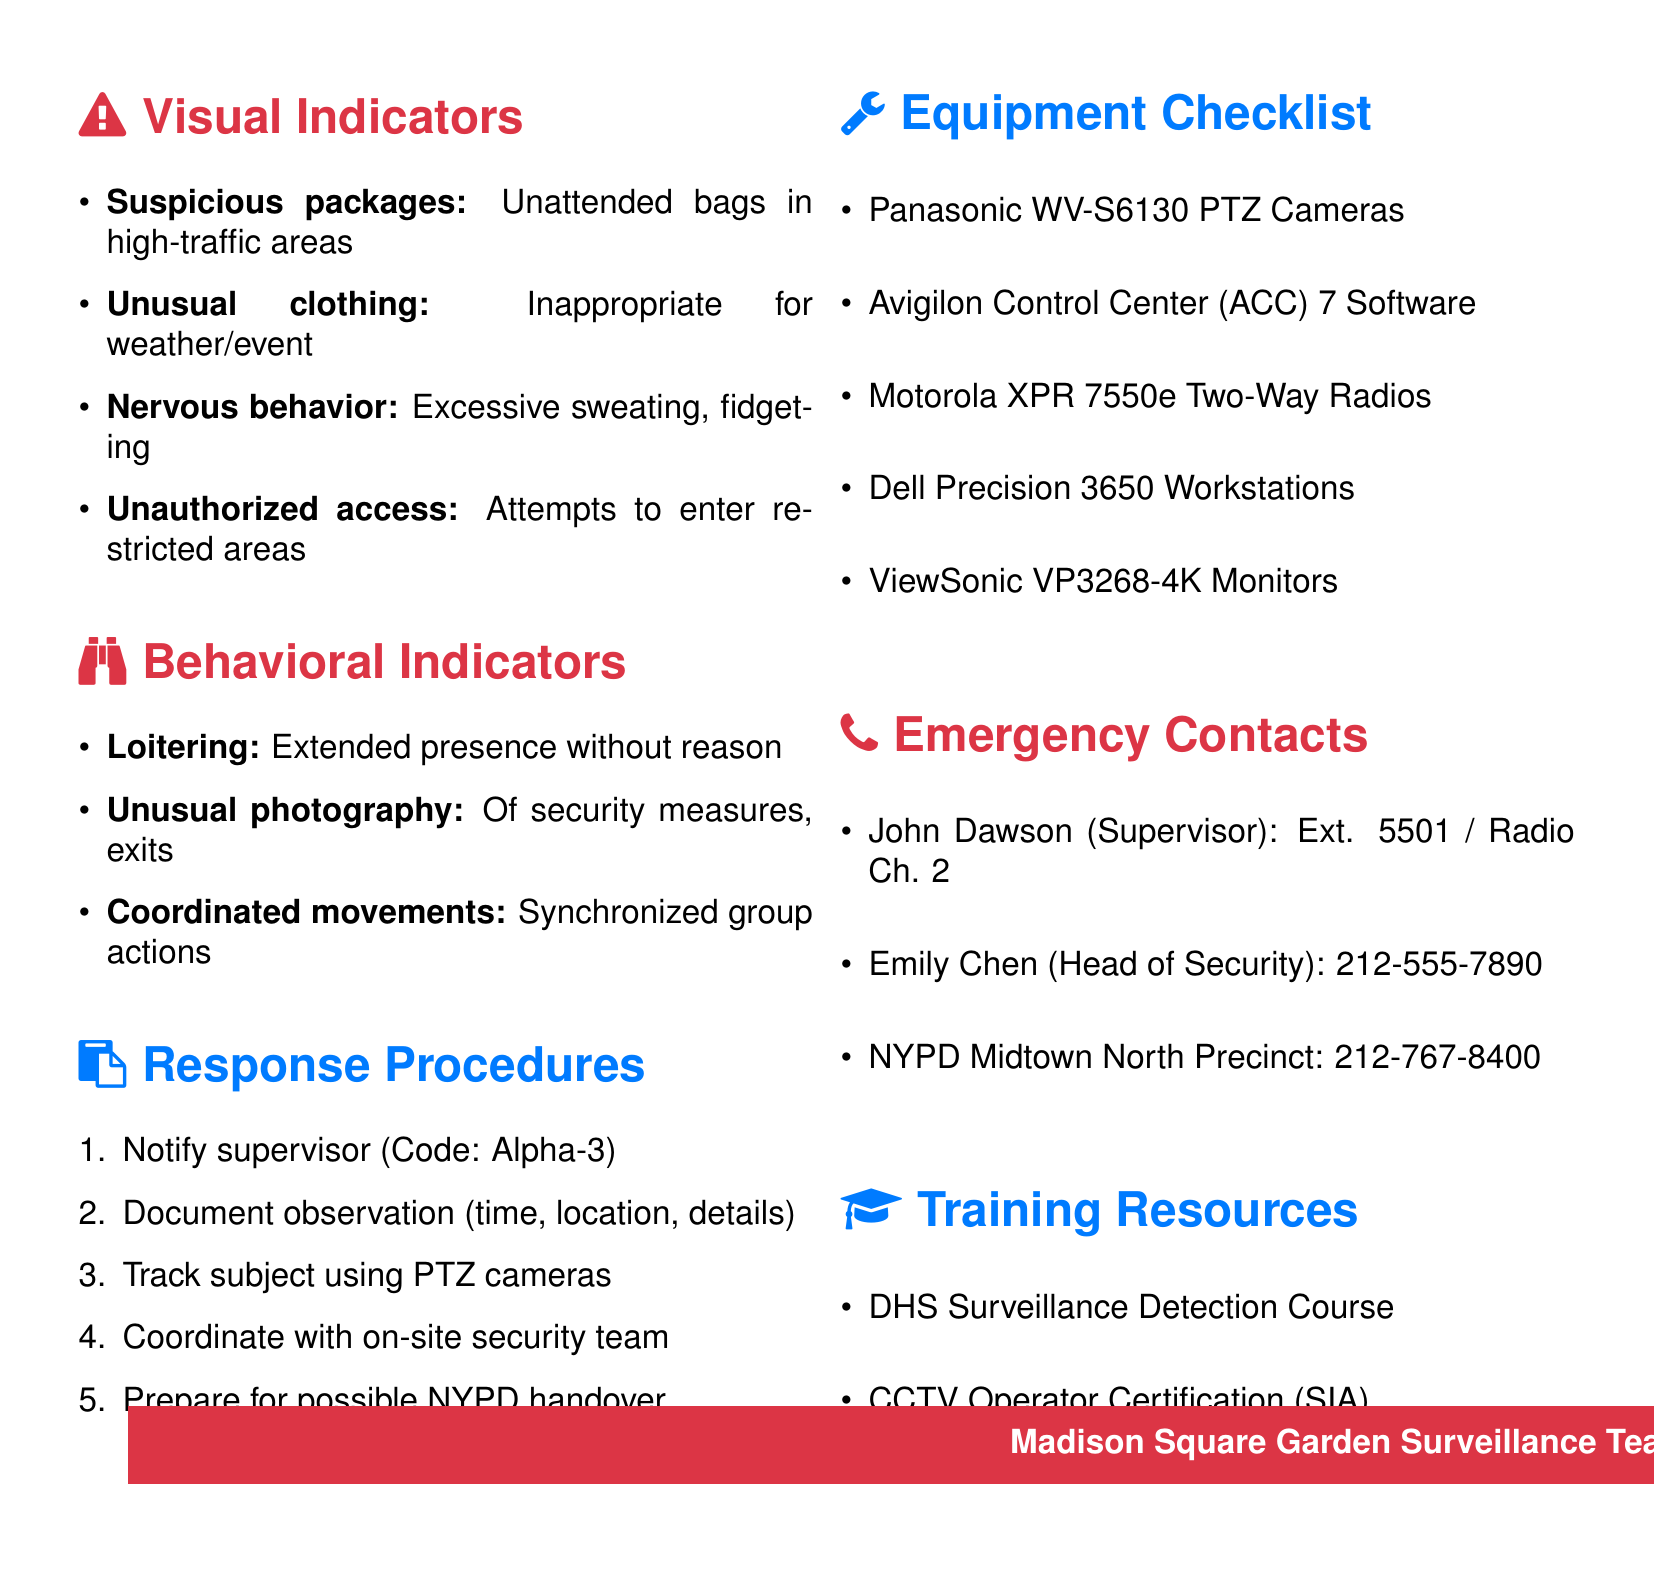what is the title of the memo? The title is located at the top of the document and describes the focus of the memo.
Answer: Training Memo: Recognizing Potential Threats in Crowded Environments who is the shift supervisor mentioned in the memo? The shift supervisor's name appears in the emergency contacts section of the document.
Answer: John Dawson how many steps are in the response procedures? The number of steps can be found by counting the listed items under response procedures.
Answer: 5 give an example of a suspicious package. An example can be found in the visual indicators section, describing a specific scenario.
Answer: A duffel bag left beneath a seat during a New York Knicks game what should you do first when you observe suspicious activity? The first action is outlined clearly at the start of the response procedures.
Answer: Notify supervisor which equipment is listed for use in surveillance? This information is contained in the equipment checklist section.
Answer: Panasonic WV-S6130 PTZ Cameras what kind of behavior should be documented? The document outlines specific behaviors that qualify for observation under the behavioral indicators.
Answer: Loitering how can you communicate with the security team? The method is described in the response procedures under coordinating actions.
Answer: Via secure communication channel 